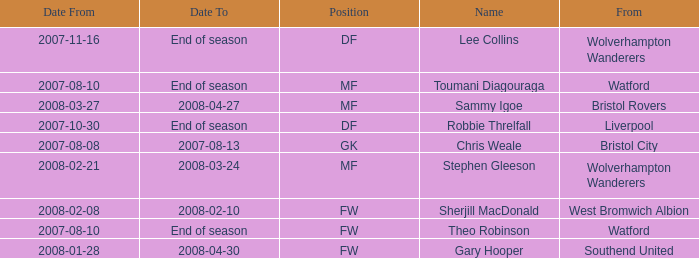What date did Toumani Diagouraga, who played position MF, start? 2007-08-10. 